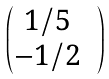Convert formula to latex. <formula><loc_0><loc_0><loc_500><loc_500>\begin{pmatrix} 1 / 5 & \\ - 1 / 2 & \end{pmatrix}</formula> 